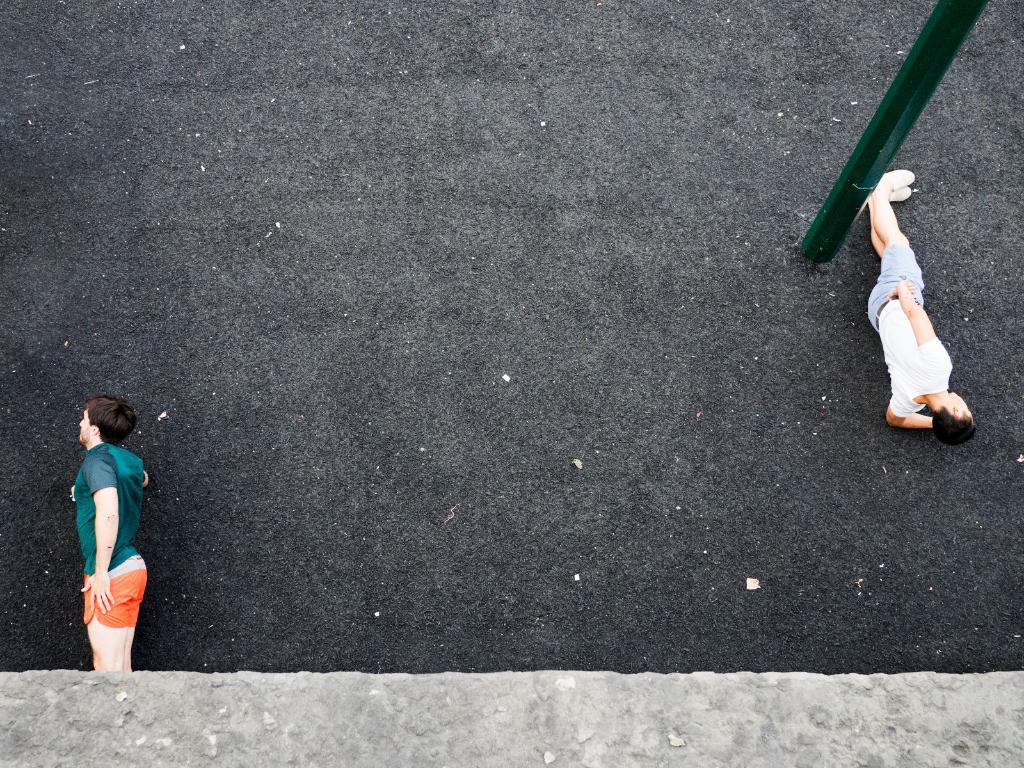Please provide a concise description of this image. In this image there is one person is lying on the ground as we can see on the left side of this image. There is one other person is also lying on the ground on the right side of this image. There is a pole on the top right side of this image. There is a ground as we can see in the middle of this image. 